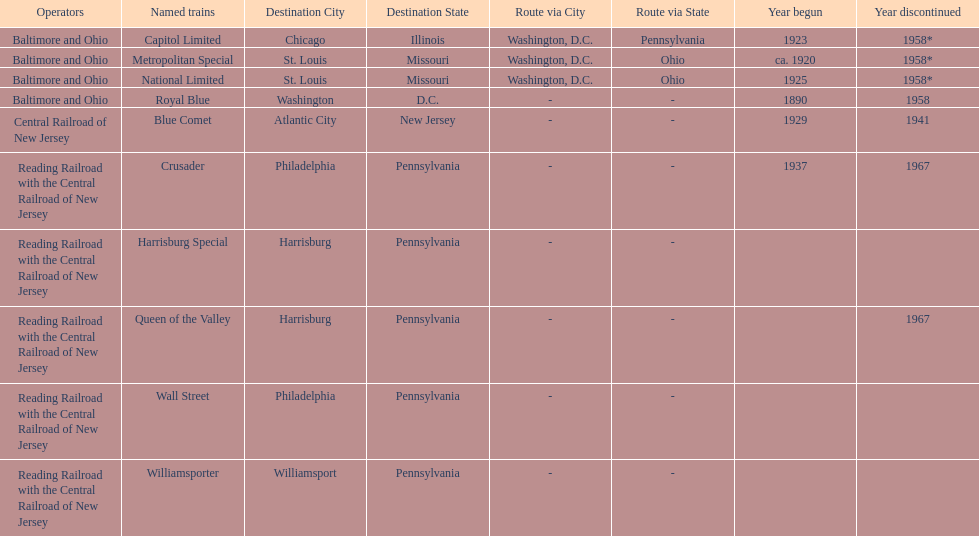What destination is at the top of the list? Chicago, Illinois via Washington, D.C. and Pittsburgh, Pennsylvania. 